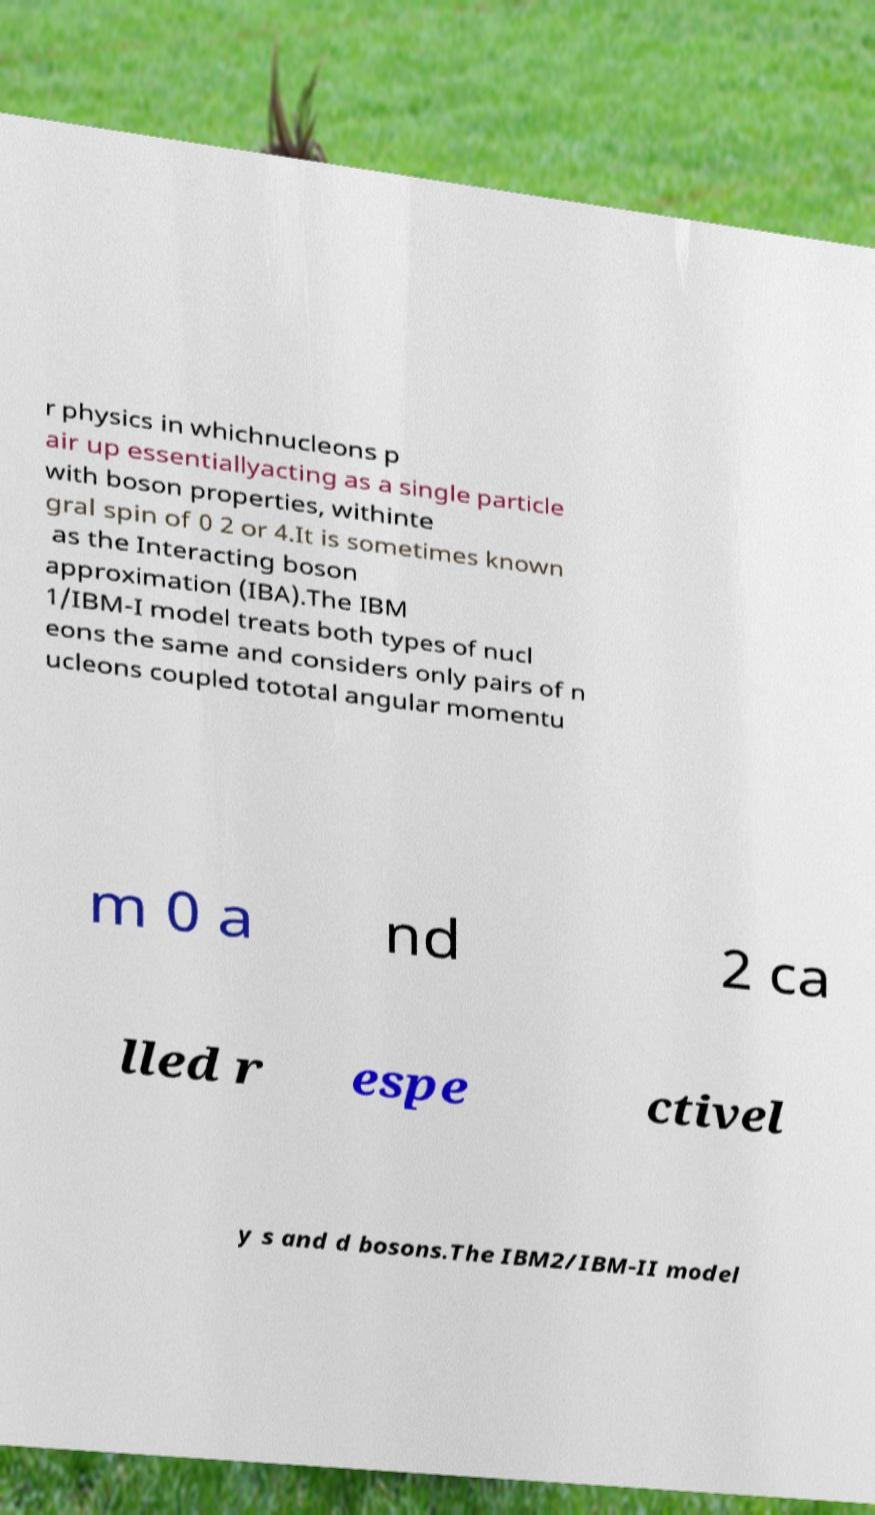I need the written content from this picture converted into text. Can you do that? r physics in whichnucleons p air up essentiallyacting as a single particle with boson properties, withinte gral spin of 0 2 or 4.It is sometimes known as the Interacting boson approximation (IBA).The IBM 1/IBM-I model treats both types of nucl eons the same and considers only pairs of n ucleons coupled tototal angular momentu m 0 a nd 2 ca lled r espe ctivel y s and d bosons.The IBM2/IBM-II model 